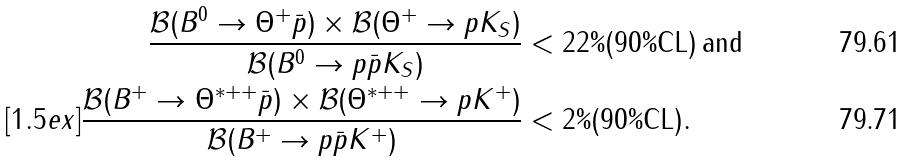<formula> <loc_0><loc_0><loc_500><loc_500>\frac { { \mathcal { B } } ( B ^ { 0 } \to \Theta ^ { + } \bar { p } ) \times { \mathcal { B } } ( \Theta ^ { + } \to p K _ { S } ) } { { \mathcal { B } } ( B ^ { 0 } \to p \bar { p } K _ { S } ) } & < 2 2 \% ( 9 0 \% \text {CL} ) \, \text {and} \\ [ 1 . 5 e x ] \frac { { \mathcal { B } } ( B ^ { + } \to \Theta ^ { * + + } \bar { p } ) \times { \mathcal { B } } ( \Theta ^ { * + + } \to p K ^ { + } ) } { { \mathcal { B } } ( B ^ { + } \to p \bar { p } K ^ { + } ) } & < 2 \% ( 9 0 \% \text {CL} ) .</formula> 